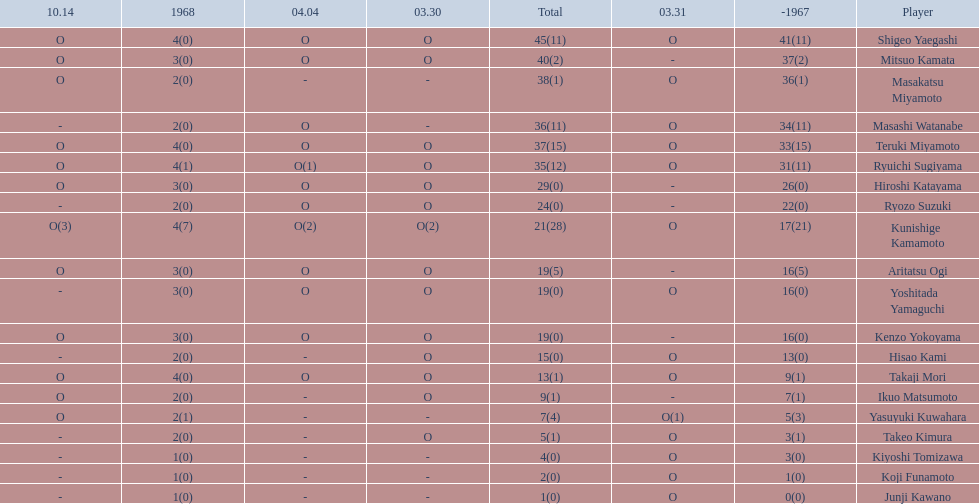How many points did takaji mori have? 13(1). And how many points did junji kawano have? 1(0). To who does the higher of these belong to? Takaji Mori. 